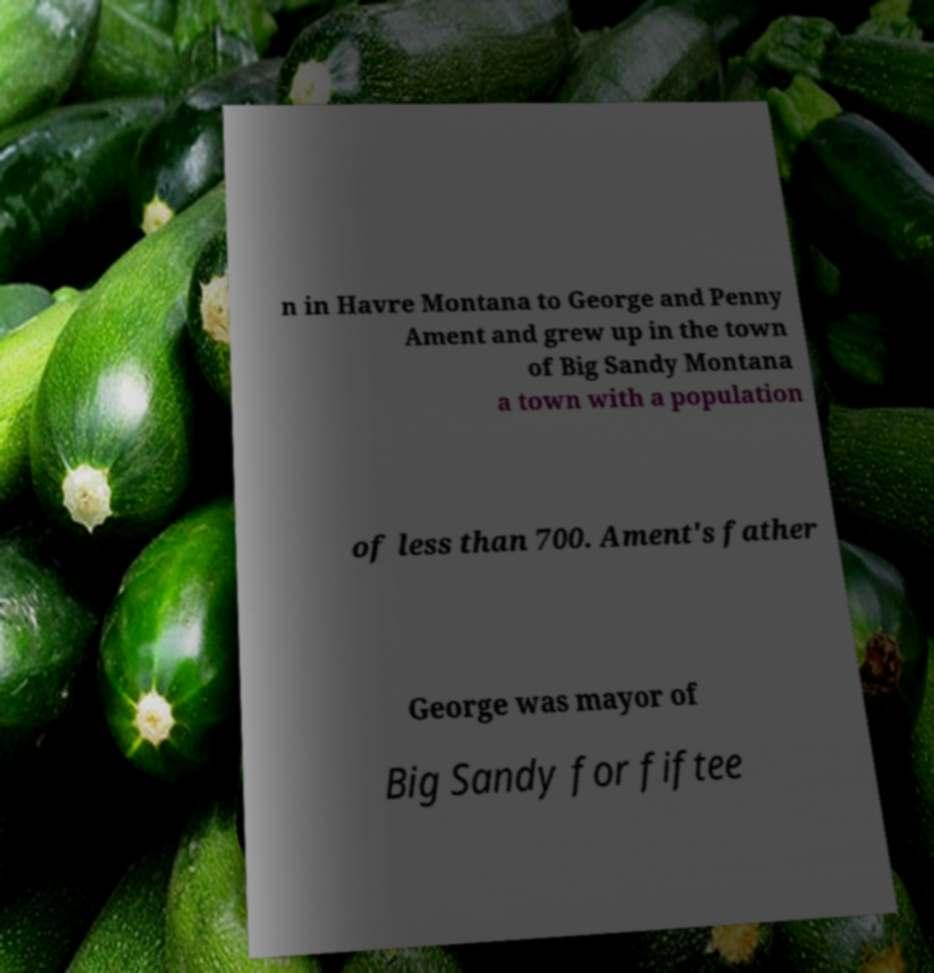Can you accurately transcribe the text from the provided image for me? n in Havre Montana to George and Penny Ament and grew up in the town of Big Sandy Montana a town with a population of less than 700. Ament's father George was mayor of Big Sandy for fiftee 